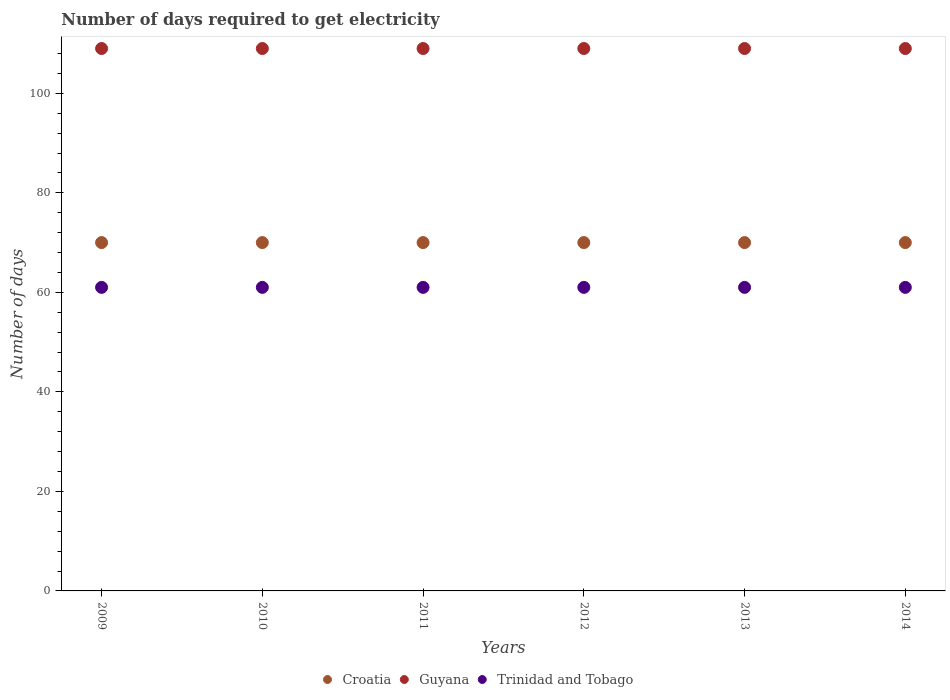What is the number of days required to get electricity in in Croatia in 2013?
Give a very brief answer. 70. Across all years, what is the maximum number of days required to get electricity in in Croatia?
Provide a short and direct response. 70. Across all years, what is the minimum number of days required to get electricity in in Guyana?
Offer a very short reply. 109. In which year was the number of days required to get electricity in in Guyana maximum?
Keep it short and to the point. 2009. What is the total number of days required to get electricity in in Trinidad and Tobago in the graph?
Your response must be concise. 366. What is the difference between the number of days required to get electricity in in Guyana in 2012 and that in 2014?
Keep it short and to the point. 0. What is the difference between the number of days required to get electricity in in Trinidad and Tobago in 2011 and the number of days required to get electricity in in Croatia in 2010?
Ensure brevity in your answer.  -9. In the year 2012, what is the difference between the number of days required to get electricity in in Trinidad and Tobago and number of days required to get electricity in in Croatia?
Your answer should be compact. -9. In how many years, is the number of days required to get electricity in in Guyana greater than 16 days?
Keep it short and to the point. 6. What is the ratio of the number of days required to get electricity in in Guyana in 2012 to that in 2013?
Your answer should be compact. 1. Is the difference between the number of days required to get electricity in in Trinidad and Tobago in 2011 and 2013 greater than the difference between the number of days required to get electricity in in Croatia in 2011 and 2013?
Give a very brief answer. No. What is the difference between the highest and the lowest number of days required to get electricity in in Croatia?
Ensure brevity in your answer.  0. In how many years, is the number of days required to get electricity in in Trinidad and Tobago greater than the average number of days required to get electricity in in Trinidad and Tobago taken over all years?
Your answer should be very brief. 0. Is the sum of the number of days required to get electricity in in Croatia in 2012 and 2013 greater than the maximum number of days required to get electricity in in Trinidad and Tobago across all years?
Provide a short and direct response. Yes. Is the number of days required to get electricity in in Croatia strictly greater than the number of days required to get electricity in in Guyana over the years?
Make the answer very short. No. How many years are there in the graph?
Offer a very short reply. 6. How many legend labels are there?
Your response must be concise. 3. How are the legend labels stacked?
Your response must be concise. Horizontal. What is the title of the graph?
Give a very brief answer. Number of days required to get electricity. Does "Cyprus" appear as one of the legend labels in the graph?
Offer a very short reply. No. What is the label or title of the X-axis?
Keep it short and to the point. Years. What is the label or title of the Y-axis?
Make the answer very short. Number of days. What is the Number of days in Guyana in 2009?
Offer a very short reply. 109. What is the Number of days in Trinidad and Tobago in 2009?
Make the answer very short. 61. What is the Number of days of Croatia in 2010?
Provide a succinct answer. 70. What is the Number of days of Guyana in 2010?
Make the answer very short. 109. What is the Number of days in Trinidad and Tobago in 2010?
Offer a terse response. 61. What is the Number of days of Guyana in 2011?
Your answer should be compact. 109. What is the Number of days of Trinidad and Tobago in 2011?
Your answer should be very brief. 61. What is the Number of days of Guyana in 2012?
Keep it short and to the point. 109. What is the Number of days in Guyana in 2013?
Keep it short and to the point. 109. What is the Number of days of Croatia in 2014?
Make the answer very short. 70. What is the Number of days in Guyana in 2014?
Your response must be concise. 109. Across all years, what is the maximum Number of days in Croatia?
Offer a very short reply. 70. Across all years, what is the maximum Number of days in Guyana?
Offer a very short reply. 109. Across all years, what is the maximum Number of days in Trinidad and Tobago?
Offer a very short reply. 61. Across all years, what is the minimum Number of days in Guyana?
Ensure brevity in your answer.  109. What is the total Number of days in Croatia in the graph?
Your answer should be compact. 420. What is the total Number of days in Guyana in the graph?
Provide a succinct answer. 654. What is the total Number of days of Trinidad and Tobago in the graph?
Provide a short and direct response. 366. What is the difference between the Number of days in Guyana in 2009 and that in 2010?
Make the answer very short. 0. What is the difference between the Number of days in Trinidad and Tobago in 2009 and that in 2010?
Provide a succinct answer. 0. What is the difference between the Number of days in Croatia in 2009 and that in 2011?
Keep it short and to the point. 0. What is the difference between the Number of days of Trinidad and Tobago in 2009 and that in 2011?
Keep it short and to the point. 0. What is the difference between the Number of days in Croatia in 2009 and that in 2012?
Your response must be concise. 0. What is the difference between the Number of days in Croatia in 2009 and that in 2013?
Offer a terse response. 0. What is the difference between the Number of days of Guyana in 2009 and that in 2013?
Provide a short and direct response. 0. What is the difference between the Number of days of Croatia in 2009 and that in 2014?
Keep it short and to the point. 0. What is the difference between the Number of days of Trinidad and Tobago in 2009 and that in 2014?
Provide a short and direct response. 0. What is the difference between the Number of days in Guyana in 2010 and that in 2012?
Your answer should be compact. 0. What is the difference between the Number of days of Trinidad and Tobago in 2010 and that in 2012?
Keep it short and to the point. 0. What is the difference between the Number of days in Croatia in 2010 and that in 2013?
Your answer should be compact. 0. What is the difference between the Number of days of Guyana in 2010 and that in 2013?
Your response must be concise. 0. What is the difference between the Number of days of Trinidad and Tobago in 2010 and that in 2013?
Give a very brief answer. 0. What is the difference between the Number of days of Guyana in 2010 and that in 2014?
Offer a terse response. 0. What is the difference between the Number of days of Trinidad and Tobago in 2011 and that in 2012?
Provide a succinct answer. 0. What is the difference between the Number of days in Croatia in 2011 and that in 2014?
Provide a short and direct response. 0. What is the difference between the Number of days in Guyana in 2011 and that in 2014?
Make the answer very short. 0. What is the difference between the Number of days of Croatia in 2012 and that in 2013?
Give a very brief answer. 0. What is the difference between the Number of days of Trinidad and Tobago in 2012 and that in 2013?
Your answer should be very brief. 0. What is the difference between the Number of days of Croatia in 2012 and that in 2014?
Give a very brief answer. 0. What is the difference between the Number of days in Guyana in 2012 and that in 2014?
Give a very brief answer. 0. What is the difference between the Number of days of Guyana in 2013 and that in 2014?
Keep it short and to the point. 0. What is the difference between the Number of days of Trinidad and Tobago in 2013 and that in 2014?
Give a very brief answer. 0. What is the difference between the Number of days of Croatia in 2009 and the Number of days of Guyana in 2010?
Offer a very short reply. -39. What is the difference between the Number of days of Guyana in 2009 and the Number of days of Trinidad and Tobago in 2010?
Keep it short and to the point. 48. What is the difference between the Number of days in Croatia in 2009 and the Number of days in Guyana in 2011?
Give a very brief answer. -39. What is the difference between the Number of days in Guyana in 2009 and the Number of days in Trinidad and Tobago in 2011?
Provide a short and direct response. 48. What is the difference between the Number of days in Croatia in 2009 and the Number of days in Guyana in 2012?
Make the answer very short. -39. What is the difference between the Number of days of Croatia in 2009 and the Number of days of Guyana in 2013?
Offer a very short reply. -39. What is the difference between the Number of days in Guyana in 2009 and the Number of days in Trinidad and Tobago in 2013?
Your answer should be compact. 48. What is the difference between the Number of days of Croatia in 2009 and the Number of days of Guyana in 2014?
Your answer should be compact. -39. What is the difference between the Number of days in Croatia in 2009 and the Number of days in Trinidad and Tobago in 2014?
Offer a terse response. 9. What is the difference between the Number of days in Croatia in 2010 and the Number of days in Guyana in 2011?
Make the answer very short. -39. What is the difference between the Number of days in Croatia in 2010 and the Number of days in Trinidad and Tobago in 2011?
Provide a short and direct response. 9. What is the difference between the Number of days in Croatia in 2010 and the Number of days in Guyana in 2012?
Your response must be concise. -39. What is the difference between the Number of days of Guyana in 2010 and the Number of days of Trinidad and Tobago in 2012?
Offer a very short reply. 48. What is the difference between the Number of days in Croatia in 2010 and the Number of days in Guyana in 2013?
Offer a terse response. -39. What is the difference between the Number of days of Croatia in 2010 and the Number of days of Trinidad and Tobago in 2013?
Your answer should be compact. 9. What is the difference between the Number of days in Croatia in 2010 and the Number of days in Guyana in 2014?
Provide a short and direct response. -39. What is the difference between the Number of days of Croatia in 2010 and the Number of days of Trinidad and Tobago in 2014?
Your answer should be compact. 9. What is the difference between the Number of days in Croatia in 2011 and the Number of days in Guyana in 2012?
Give a very brief answer. -39. What is the difference between the Number of days of Croatia in 2011 and the Number of days of Trinidad and Tobago in 2012?
Give a very brief answer. 9. What is the difference between the Number of days of Guyana in 2011 and the Number of days of Trinidad and Tobago in 2012?
Make the answer very short. 48. What is the difference between the Number of days in Croatia in 2011 and the Number of days in Guyana in 2013?
Offer a terse response. -39. What is the difference between the Number of days of Croatia in 2011 and the Number of days of Trinidad and Tobago in 2013?
Offer a terse response. 9. What is the difference between the Number of days of Croatia in 2011 and the Number of days of Guyana in 2014?
Keep it short and to the point. -39. What is the difference between the Number of days in Guyana in 2011 and the Number of days in Trinidad and Tobago in 2014?
Ensure brevity in your answer.  48. What is the difference between the Number of days of Croatia in 2012 and the Number of days of Guyana in 2013?
Offer a very short reply. -39. What is the difference between the Number of days in Croatia in 2012 and the Number of days in Trinidad and Tobago in 2013?
Give a very brief answer. 9. What is the difference between the Number of days in Croatia in 2012 and the Number of days in Guyana in 2014?
Your response must be concise. -39. What is the difference between the Number of days of Croatia in 2013 and the Number of days of Guyana in 2014?
Offer a terse response. -39. What is the difference between the Number of days in Guyana in 2013 and the Number of days in Trinidad and Tobago in 2014?
Offer a very short reply. 48. What is the average Number of days of Croatia per year?
Give a very brief answer. 70. What is the average Number of days in Guyana per year?
Make the answer very short. 109. In the year 2009, what is the difference between the Number of days in Croatia and Number of days in Guyana?
Offer a terse response. -39. In the year 2009, what is the difference between the Number of days in Croatia and Number of days in Trinidad and Tobago?
Your response must be concise. 9. In the year 2010, what is the difference between the Number of days of Croatia and Number of days of Guyana?
Provide a short and direct response. -39. In the year 2011, what is the difference between the Number of days of Croatia and Number of days of Guyana?
Make the answer very short. -39. In the year 2012, what is the difference between the Number of days of Croatia and Number of days of Guyana?
Give a very brief answer. -39. In the year 2012, what is the difference between the Number of days of Croatia and Number of days of Trinidad and Tobago?
Offer a terse response. 9. In the year 2013, what is the difference between the Number of days in Croatia and Number of days in Guyana?
Your answer should be compact. -39. In the year 2013, what is the difference between the Number of days in Croatia and Number of days in Trinidad and Tobago?
Offer a very short reply. 9. In the year 2013, what is the difference between the Number of days in Guyana and Number of days in Trinidad and Tobago?
Provide a short and direct response. 48. In the year 2014, what is the difference between the Number of days in Croatia and Number of days in Guyana?
Provide a succinct answer. -39. In the year 2014, what is the difference between the Number of days in Croatia and Number of days in Trinidad and Tobago?
Your response must be concise. 9. In the year 2014, what is the difference between the Number of days of Guyana and Number of days of Trinidad and Tobago?
Keep it short and to the point. 48. What is the ratio of the Number of days of Croatia in 2009 to that in 2010?
Provide a short and direct response. 1. What is the ratio of the Number of days in Croatia in 2009 to that in 2011?
Keep it short and to the point. 1. What is the ratio of the Number of days in Trinidad and Tobago in 2009 to that in 2011?
Provide a succinct answer. 1. What is the ratio of the Number of days of Croatia in 2009 to that in 2013?
Offer a very short reply. 1. What is the ratio of the Number of days of Guyana in 2009 to that in 2013?
Your answer should be compact. 1. What is the ratio of the Number of days in Trinidad and Tobago in 2009 to that in 2013?
Offer a very short reply. 1. What is the ratio of the Number of days of Trinidad and Tobago in 2009 to that in 2014?
Offer a terse response. 1. What is the ratio of the Number of days of Guyana in 2010 to that in 2012?
Offer a terse response. 1. What is the ratio of the Number of days of Trinidad and Tobago in 2010 to that in 2012?
Offer a very short reply. 1. What is the ratio of the Number of days in Croatia in 2010 to that in 2013?
Provide a succinct answer. 1. What is the ratio of the Number of days of Guyana in 2010 to that in 2013?
Offer a very short reply. 1. What is the ratio of the Number of days of Croatia in 2010 to that in 2014?
Make the answer very short. 1. What is the ratio of the Number of days of Guyana in 2010 to that in 2014?
Keep it short and to the point. 1. What is the ratio of the Number of days in Trinidad and Tobago in 2010 to that in 2014?
Ensure brevity in your answer.  1. What is the ratio of the Number of days of Croatia in 2011 to that in 2012?
Make the answer very short. 1. What is the ratio of the Number of days of Guyana in 2011 to that in 2012?
Make the answer very short. 1. What is the ratio of the Number of days of Trinidad and Tobago in 2011 to that in 2012?
Ensure brevity in your answer.  1. What is the ratio of the Number of days of Croatia in 2011 to that in 2014?
Your response must be concise. 1. What is the ratio of the Number of days of Guyana in 2011 to that in 2014?
Ensure brevity in your answer.  1. What is the ratio of the Number of days of Trinidad and Tobago in 2012 to that in 2013?
Ensure brevity in your answer.  1. What is the ratio of the Number of days in Croatia in 2012 to that in 2014?
Provide a succinct answer. 1. What is the ratio of the Number of days in Croatia in 2013 to that in 2014?
Give a very brief answer. 1. What is the ratio of the Number of days of Trinidad and Tobago in 2013 to that in 2014?
Make the answer very short. 1. What is the difference between the highest and the second highest Number of days in Croatia?
Make the answer very short. 0. What is the difference between the highest and the second highest Number of days of Trinidad and Tobago?
Ensure brevity in your answer.  0. What is the difference between the highest and the lowest Number of days of Guyana?
Make the answer very short. 0. 